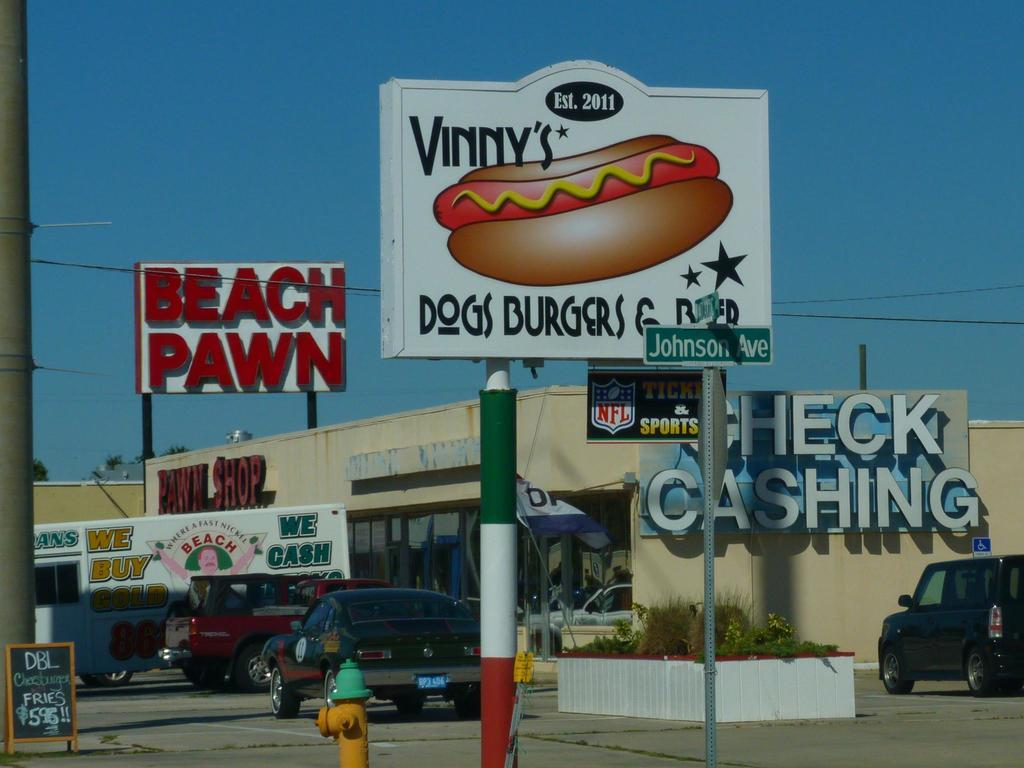<image>
Offer a succinct explanation of the picture presented. A building that says Check Casing has next to a shop that says Beach Pawn. 